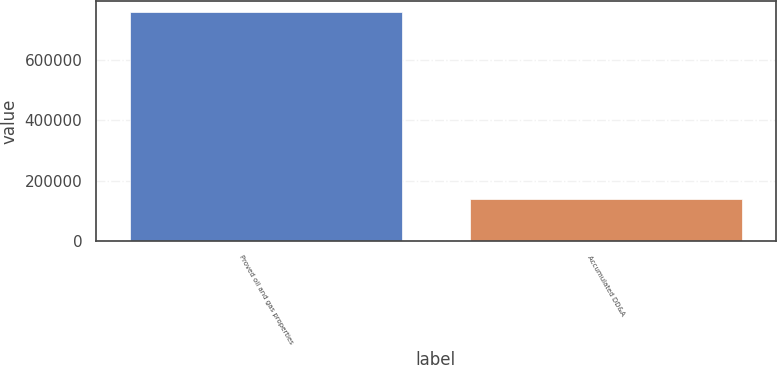Convert chart to OTSL. <chart><loc_0><loc_0><loc_500><loc_500><bar_chart><fcel>Proved oil and gas properties<fcel>Accumulated DD&A<nl><fcel>757885<fcel>138425<nl></chart> 